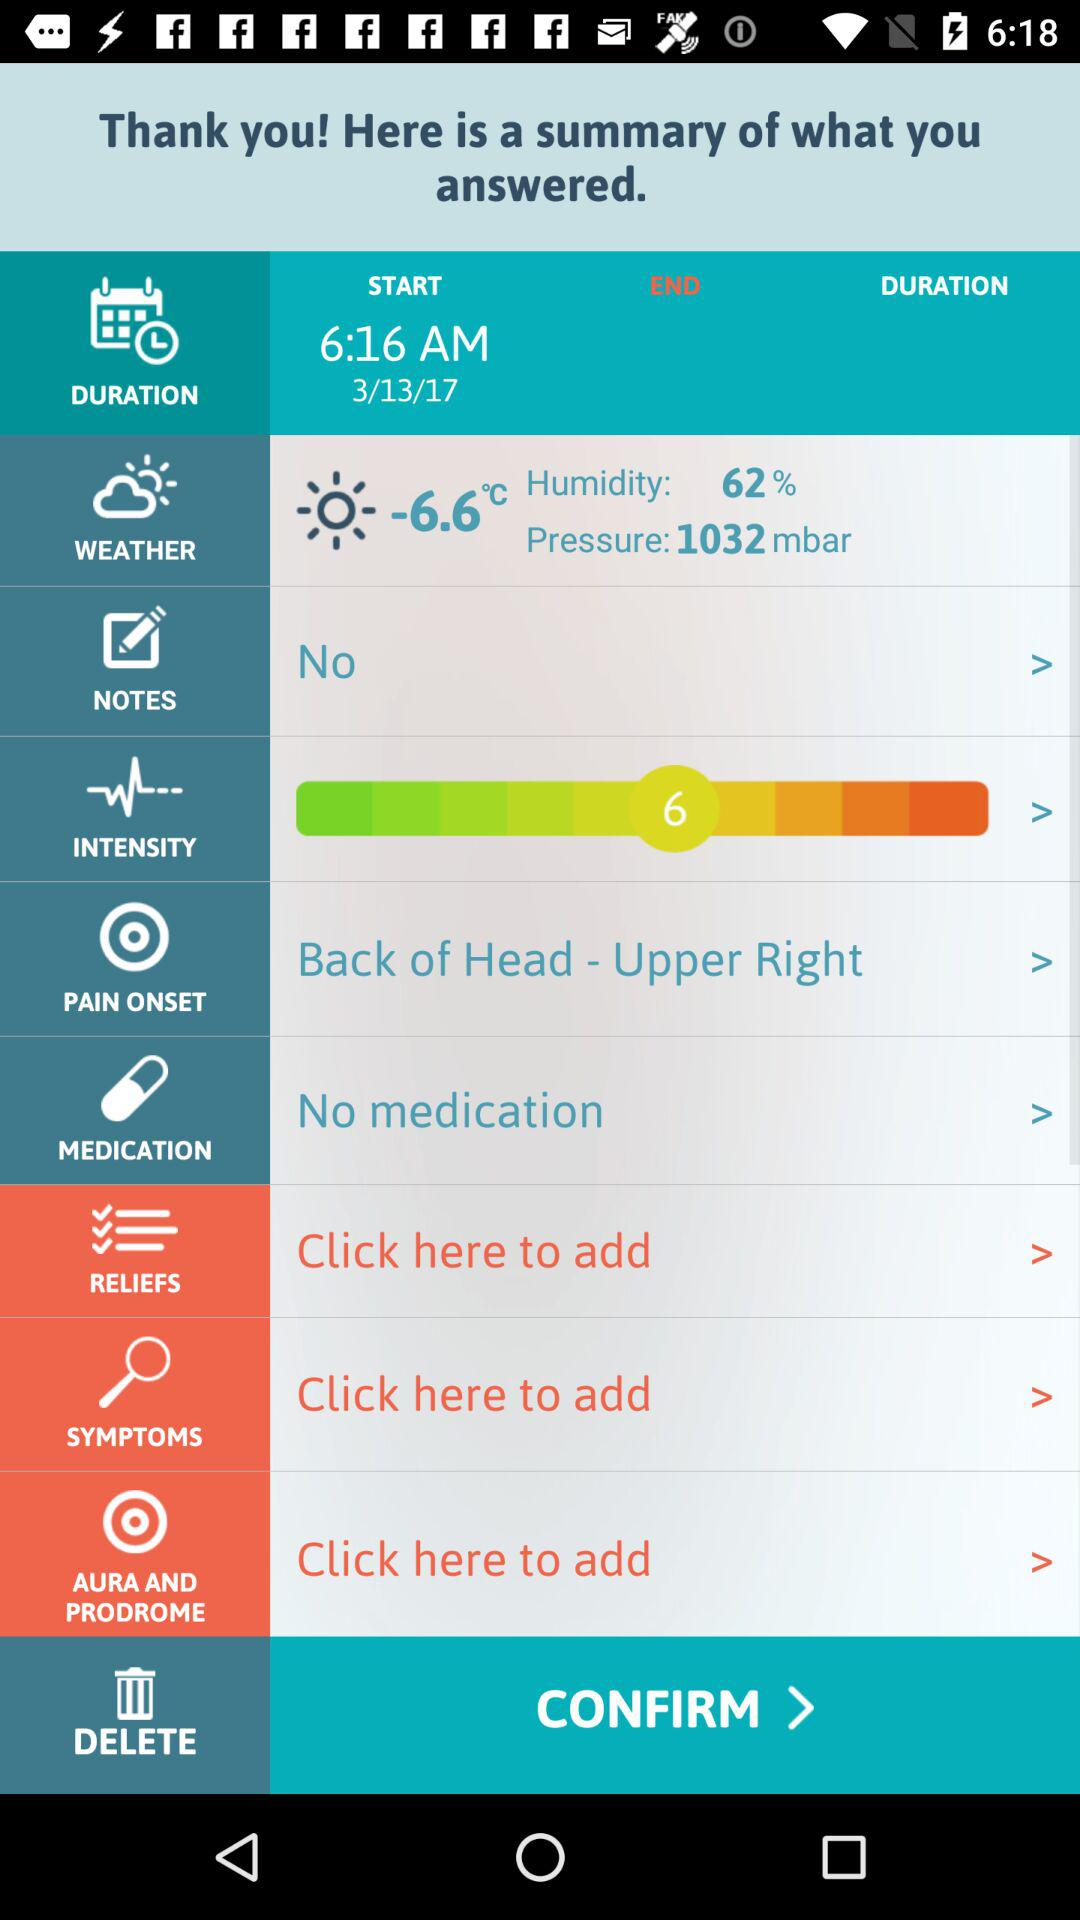What is the pressure? The pressure is 1032 mbar. 